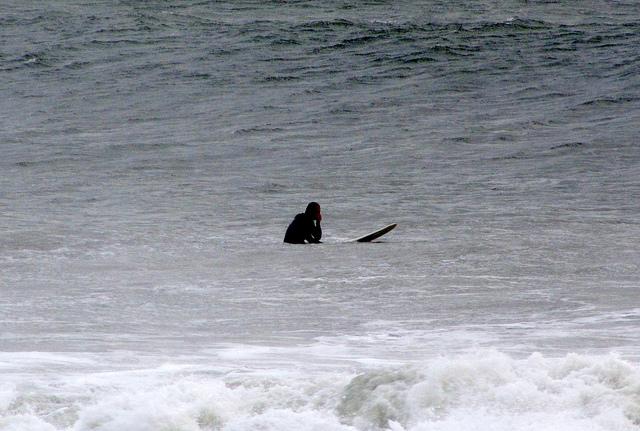Is it cold in the water?
Short answer required. Yes. What is the white stuff on the ground?
Write a very short answer. Water. What color is the water?
Keep it brief. Blue. What is the surfer waiting for?
Concise answer only. Wave. Is the water calm or rapid?
Keep it brief. Calm. Do they need to do a lot of paddling to get to this location?
Write a very short answer. Yes. Is the surfer wearing a wetsuit?
Write a very short answer. Yes. Is this a river?
Keep it brief. No. 